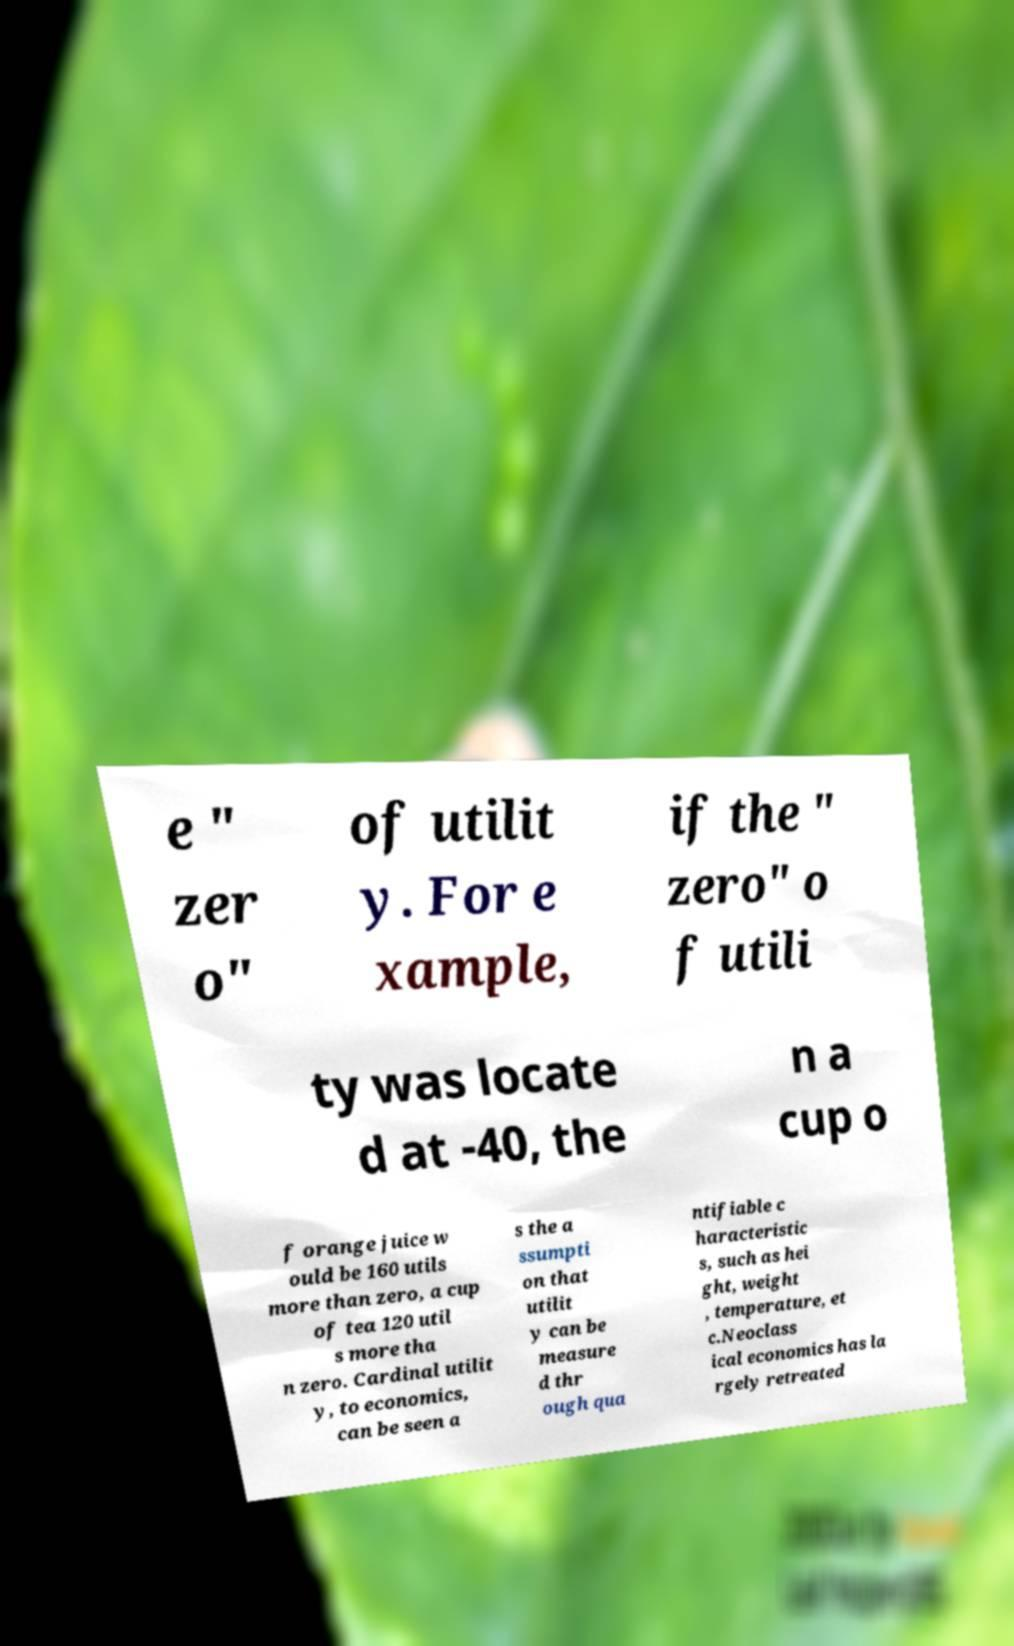Could you assist in decoding the text presented in this image and type it out clearly? e " zer o" of utilit y. For e xample, if the " zero" o f utili ty was locate d at -40, the n a cup o f orange juice w ould be 160 utils more than zero, a cup of tea 120 util s more tha n zero. Cardinal utilit y, to economics, can be seen a s the a ssumpti on that utilit y can be measure d thr ough qua ntifiable c haracteristic s, such as hei ght, weight , temperature, et c.Neoclass ical economics has la rgely retreated 